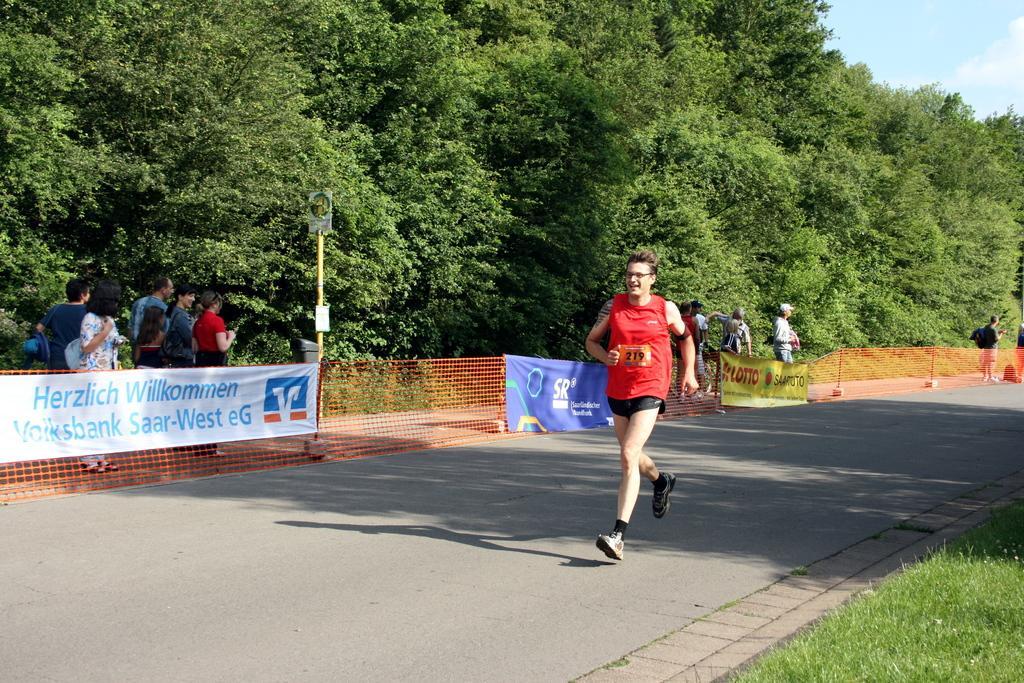Could you give a brief overview of what you see in this image? In the image there is a man running on the road and around the man there are banners and there is a fencing behind the banners. Behind the fencing there are few people, in the background there are plenty of trees. 